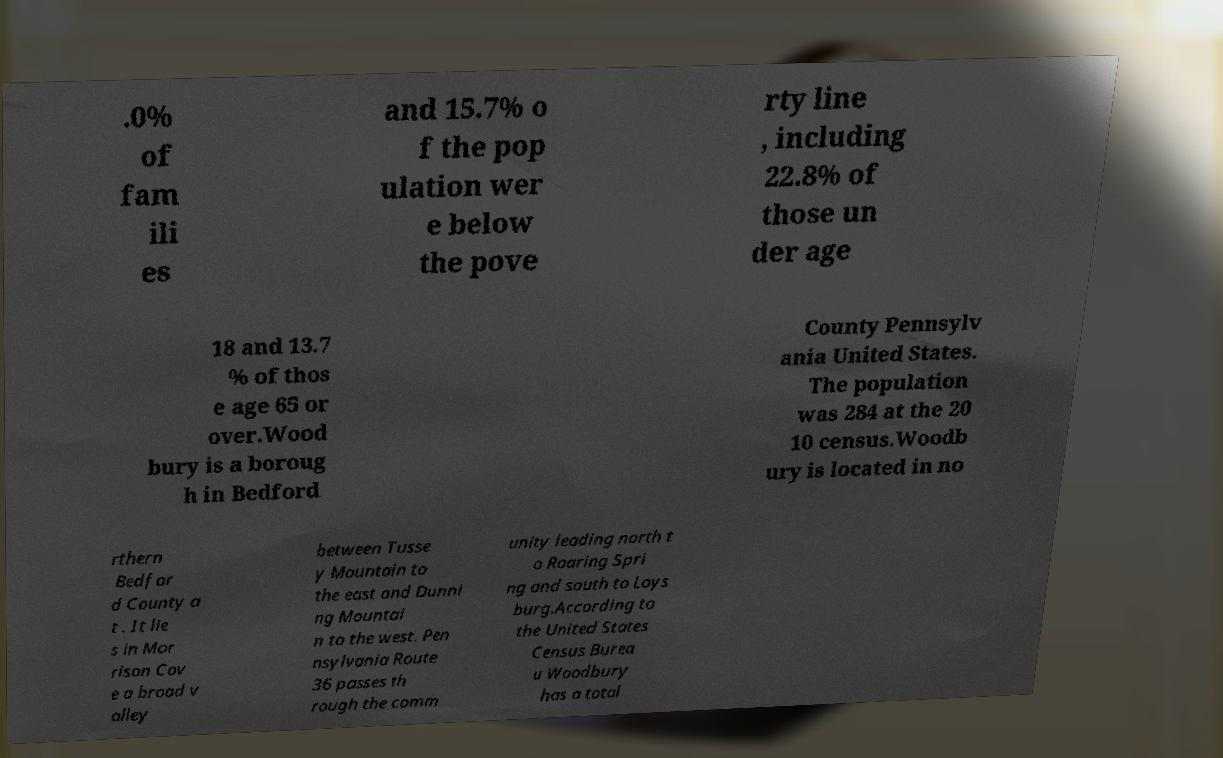Please read and relay the text visible in this image. What does it say? .0% of fam ili es and 15.7% o f the pop ulation wer e below the pove rty line , including 22.8% of those un der age 18 and 13.7 % of thos e age 65 or over.Wood bury is a boroug h in Bedford County Pennsylv ania United States. The population was 284 at the 20 10 census.Woodb ury is located in no rthern Bedfor d County a t . It lie s in Mor rison Cov e a broad v alley between Tusse y Mountain to the east and Dunni ng Mountai n to the west. Pen nsylvania Route 36 passes th rough the comm unity leading north t o Roaring Spri ng and south to Loys burg.According to the United States Census Burea u Woodbury has a total 